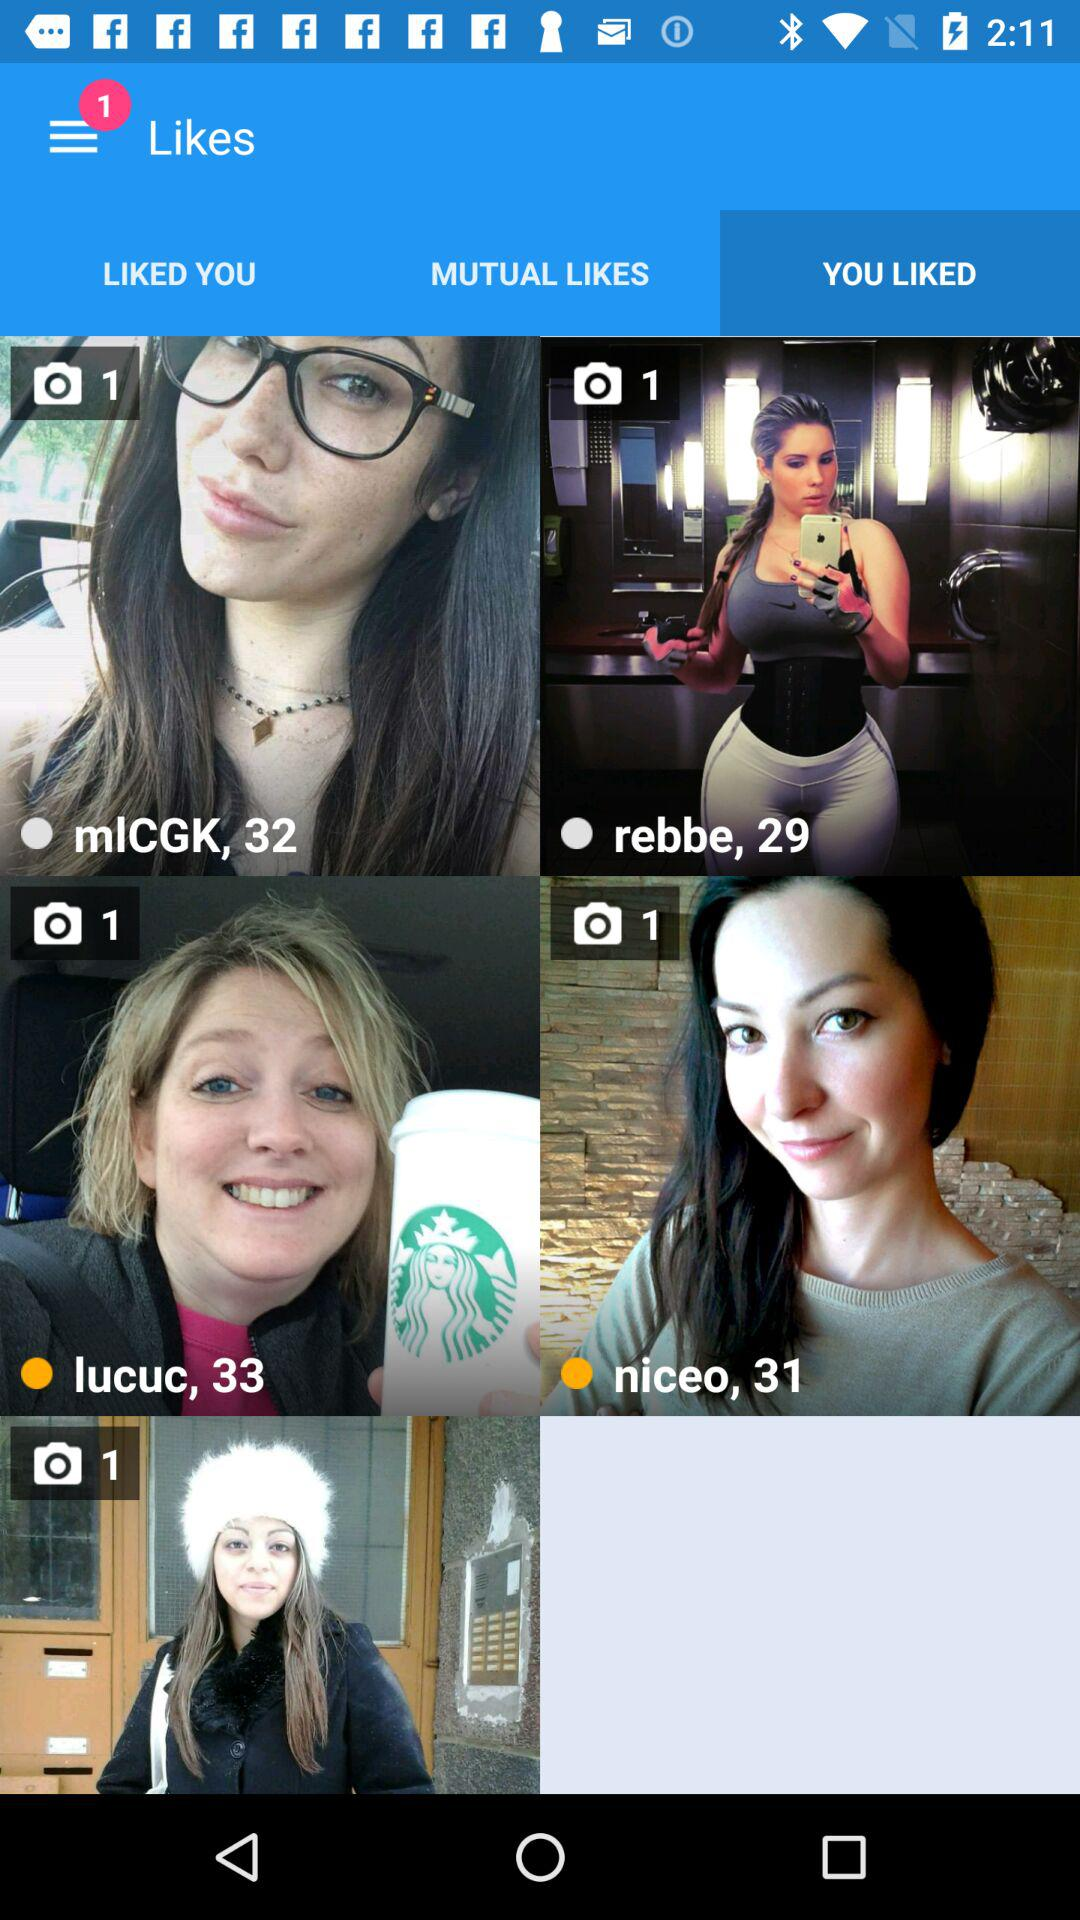How many photos have been posted by Rebbe? The photo posted by Rebbe is 1. 